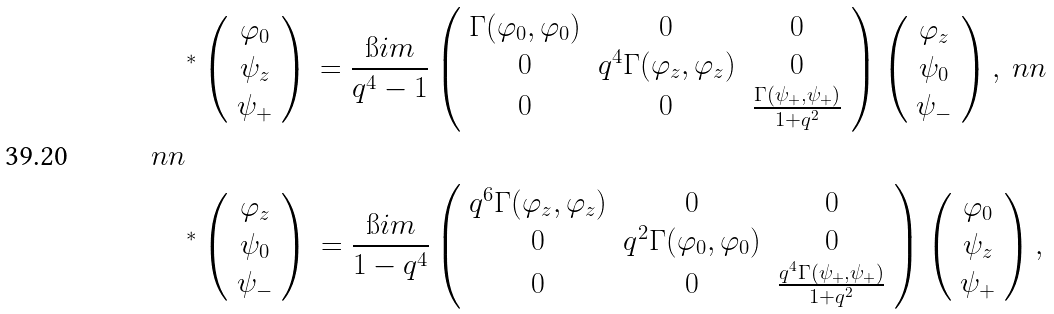Convert formula to latex. <formula><loc_0><loc_0><loc_500><loc_500>& ^ { * } \left ( \begin{array} { c } \varphi _ { 0 } \\ \psi _ { z } \\ \psi _ { + } \end{array} \right ) \, = \frac { \i i m } { q ^ { 4 } - 1 } \left ( \begin{array} { c c c } \Gamma ( \varphi _ { 0 } , \varphi _ { 0 } ) & 0 & 0 \\ 0 & q ^ { 4 } \Gamma ( \varphi _ { z } , \varphi _ { z } ) & 0 \\ 0 & 0 & \frac { \Gamma ( \psi _ { + } , \psi _ { + } ) } { 1 + q ^ { 2 } } \end{array} \right ) \left ( \begin{array} { c } \varphi _ { z } \\ \psi _ { 0 } \\ \psi _ { - } \end{array} \right ) , \ n n \\ \ n n \\ & ^ { * } \left ( \begin{array} { c } \varphi _ { z } \\ \psi _ { 0 } \\ \psi _ { - } \end{array} \right ) \, = \frac { \i i m } { 1 - q ^ { 4 } } \left ( \begin{array} { c c c } q ^ { 6 } \Gamma ( \varphi _ { z } , \varphi _ { z } ) & 0 & 0 \\ 0 & q ^ { 2 } \Gamma ( \varphi _ { 0 } , \varphi _ { 0 } ) & 0 \\ 0 & 0 & \frac { q ^ { 4 } \Gamma ( \psi _ { + } , \psi _ { + } ) } { 1 + q ^ { 2 } } \end{array} \right ) \left ( \begin{array} { c } \varphi _ { 0 } \\ \psi _ { z } \\ \psi _ { + } \end{array} \right ) ,</formula> 